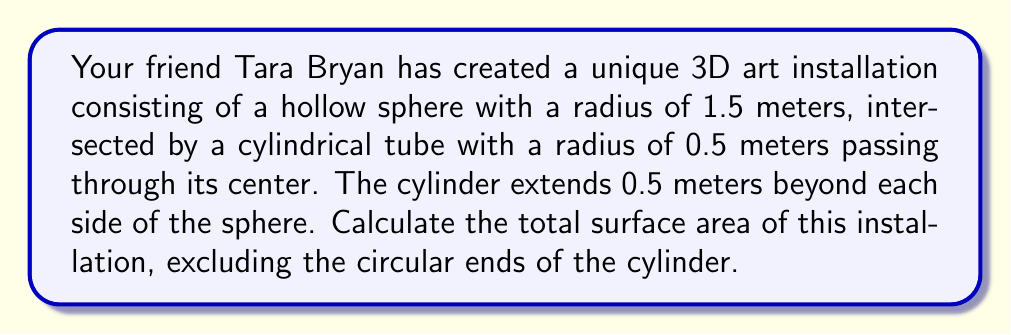Help me with this question. Let's approach this problem step-by-step:

1. Surface area of the sphere:
   The surface area of a sphere is given by the formula $A_{sphere} = 4\pi r^2$.
   $$A_{sphere} = 4\pi (1.5)^2 = 4\pi (2.25) = 9\pi \text{ m}^2$$

2. Area of the circular holes in the sphere:
   The area of a circle is $\pi r^2$, and there are two holes.
   $$A_{holes} = 2\pi (0.5)^2 = 2\pi (0.25) = 0.5\pi \text{ m}^2$$

3. Remaining surface area of the sphere:
   $$A_{remaining sphere} = A_{sphere} - A_{holes} = 9\pi - 0.5\pi = 8.5\pi \text{ m}^2$$

4. Surface area of the cylinder:
   The surface area of a cylinder (excluding ends) is given by $2\pi rh$, where $r$ is the radius and $h$ is the height.
   The total height of the cylinder is $2(0.5) + 2(1.5) = 4 \text{ m}$.
   $$A_{cylinder} = 2\pi (0.5)(4) = 4\pi \text{ m}^2$$

5. Total surface area:
   $$A_{total} = A_{remaining sphere} + A_{cylinder} = 8.5\pi + 4\pi = 12.5\pi \text{ m}^2$$

[asy]
import three;

size(200);
currentprojection=perspective(6,3,2);

// Draw sphere
draw(surface(sphere(O,1.5)),paleblue+opacity(0.3));

// Draw cylinder
path3 p=circle(O,0.5,Z);
draw(surface(p,2Z--(-2Z)),paleyellow+opacity(0.5));
draw(shift(2Z)*p);
draw(shift(-2Z)*p);

// Labels
label("1.5m",O--1.5X,E);
label("0.5m",O--0.5Y,N);
label("2m",2Z,W);
[/asy]
Answer: $12.5\pi \text{ m}^2$ 